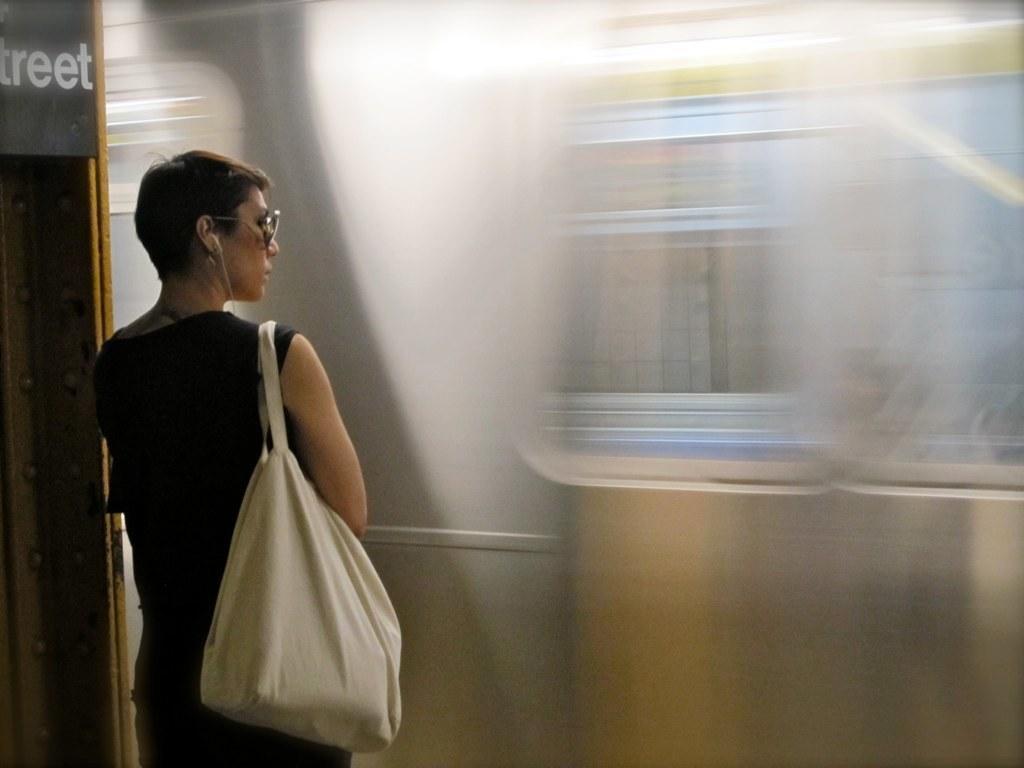Please provide a concise description of this image. In this image, in the left side there is a woman she is standing and she is carrying a white color bag. 